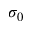<formula> <loc_0><loc_0><loc_500><loc_500>\sigma _ { 0 }</formula> 